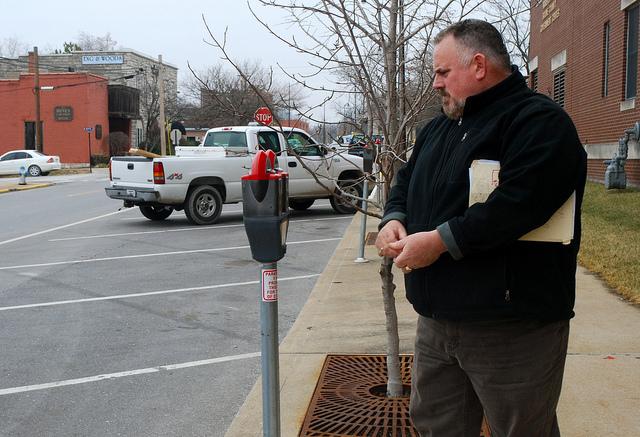Is this man upset?
Give a very brief answer. No. What is the man holding under his arm?
Be succinct. Folder. What is the man doing?
Keep it brief. Paying parking meter. 